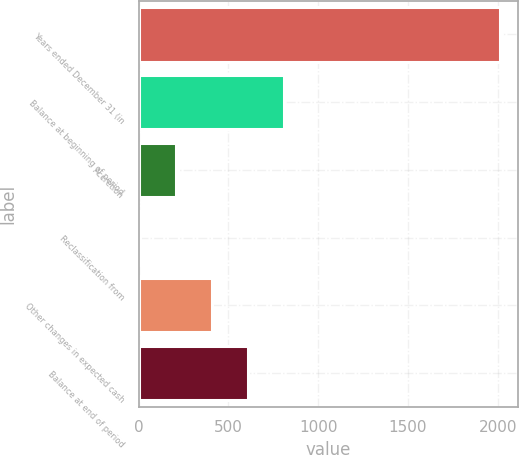Convert chart. <chart><loc_0><loc_0><loc_500><loc_500><bar_chart><fcel>Years ended December 31 (in<fcel>Balance at beginning of period<fcel>Accretion<fcel>Reclassification from<fcel>Other changes in expected cash<fcel>Balance at end of period<nl><fcel>2014<fcel>809.62<fcel>207.43<fcel>6.7<fcel>408.16<fcel>608.89<nl></chart> 